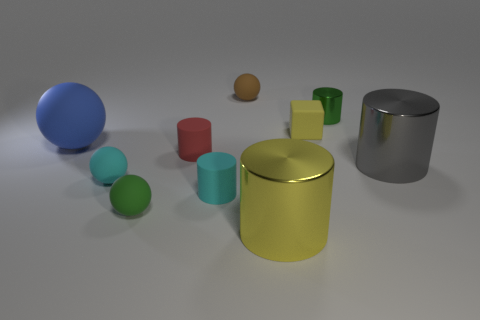Could you describe the lighting of the scene? Certainly. The scene is illuminated by a diffuse overhead light source, creating soft shadows that gently outline the objects on the ground. This lighting suggests an interior setting, possibly within a studio where the light is evenly spread to avoid harsh reflections, particularly noticeable on the shiny surfaces of the metallic objects. 